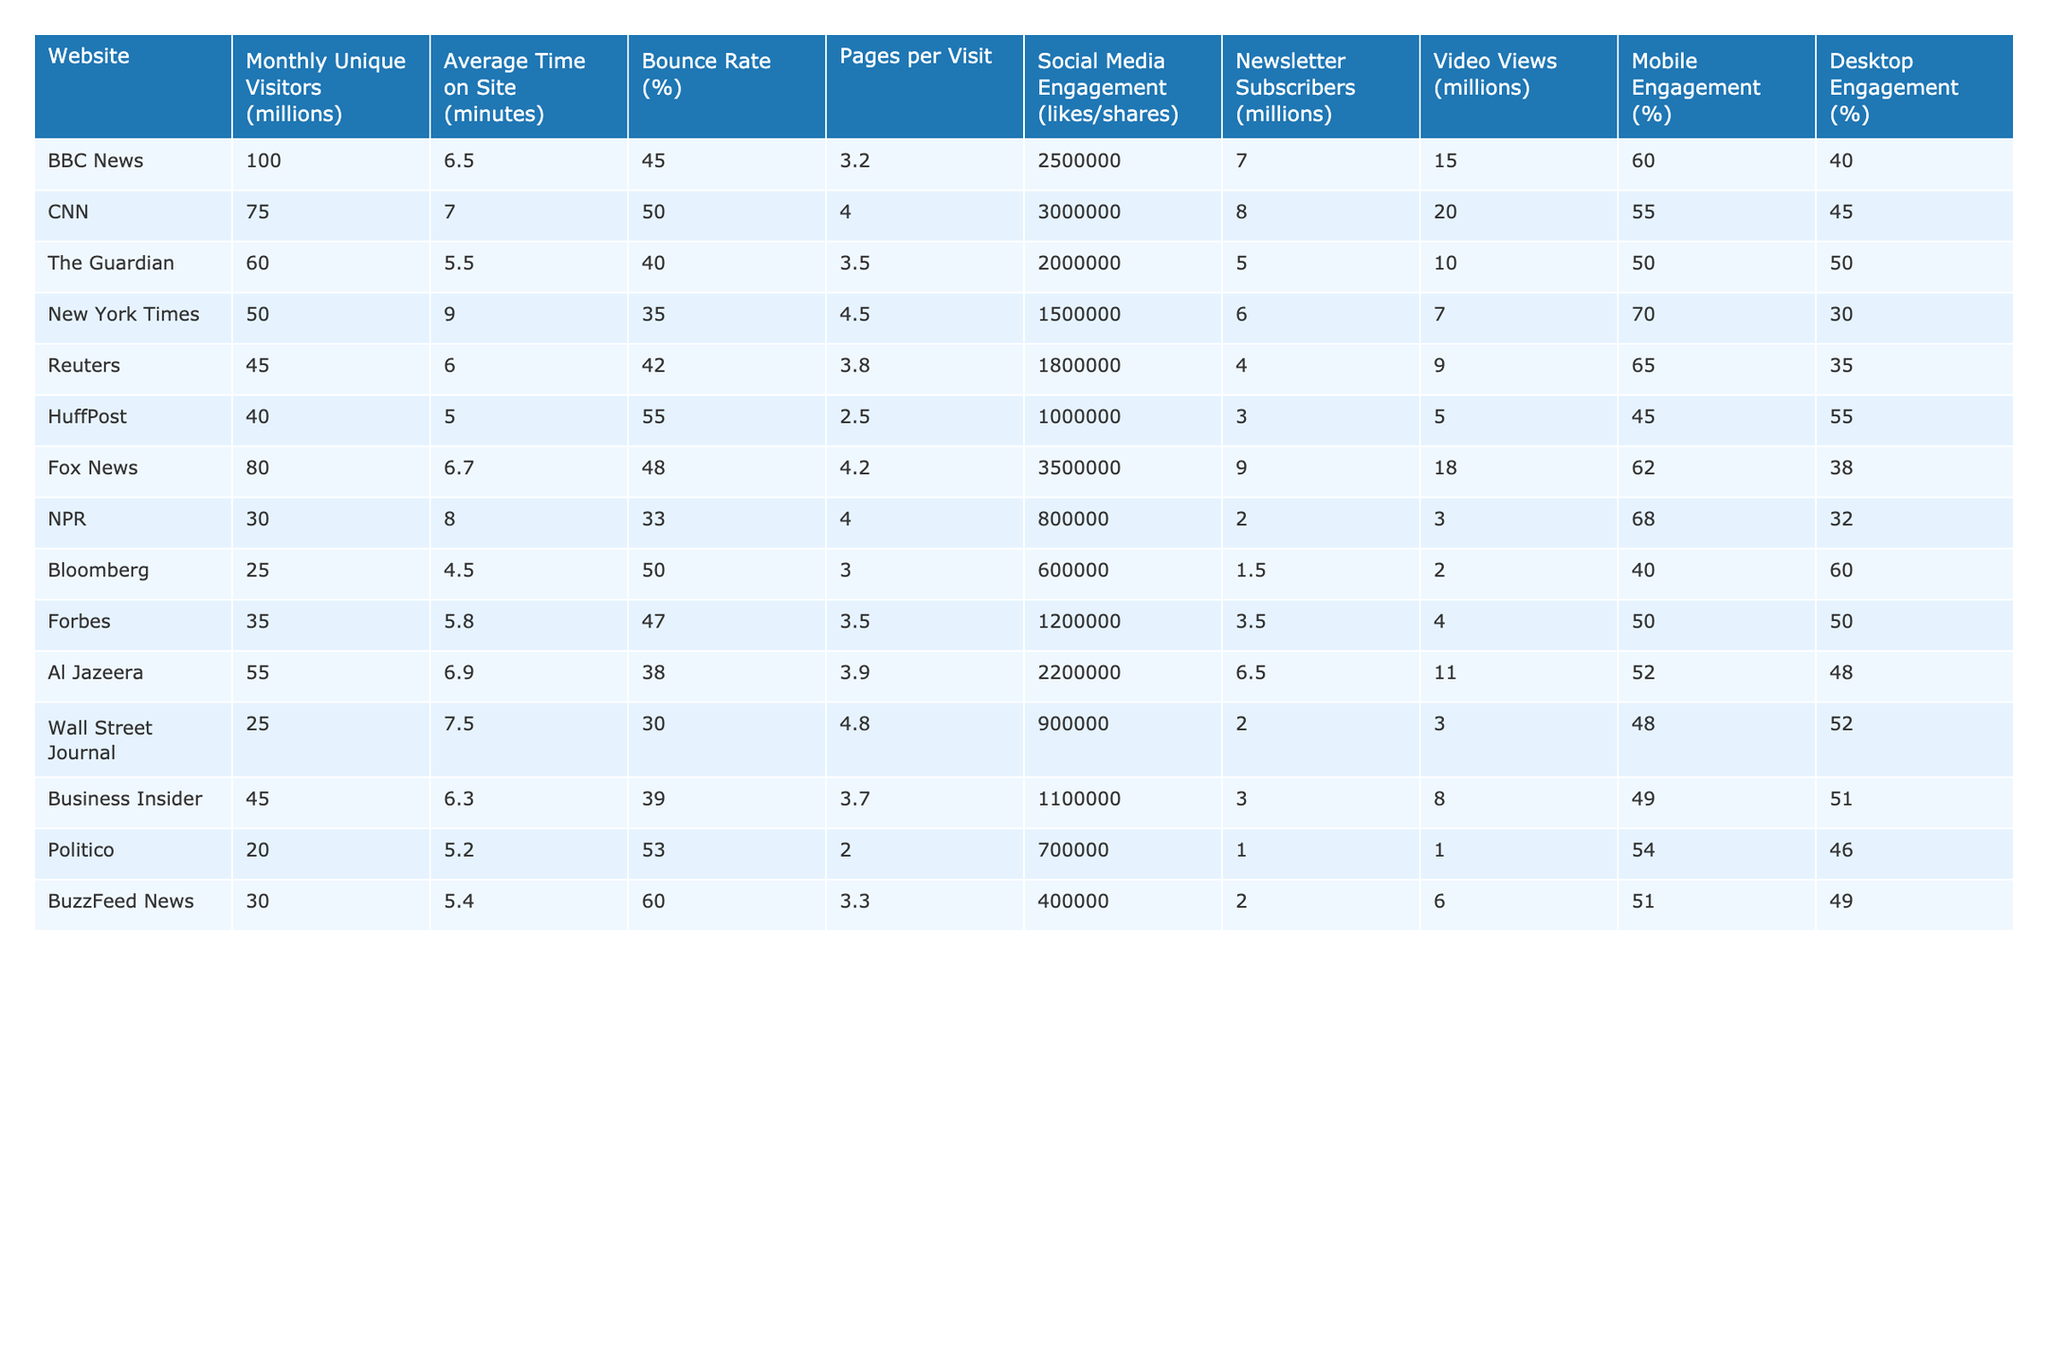What is the website with the highest monthly unique visitors? The table shows that BBC News has the highest monthly unique visitors at 100 million.
Answer: BBC News Which website has the lowest average time on site? Bloomberg has the lowest average time on site at 4.5 minutes.
Answer: Bloomberg What is the bounce rate for The Guardian? The bounce rate for The Guardian is 40%.
Answer: 40% Which two websites have a mobile engagement percentage greater than 60%? The websites NPR (68%) and BBC News (60%) have mobile engagement percentages greater than 60%.
Answer: NPR and BBC News What is the average number of social media engagements for the top five websites based on monthly unique visitors? Adding the social media engagements: 2,500,000 + 3,000,000 + 2,000,000 + 1,500,000 + 2,200,000 = 11,200,000; dividing by 5 gives an average of 2,240,000.
Answer: 2,240,000 Is the average number of pages per visit for CNN higher than that of Fox News? CNN has 4.0 pages per visit, while Fox News has 4.2, which is higher. Therefore, the statement is false.
Answer: No What is the difference in mobile engagement percentage between the highest and lowest? The highest mobile engagement is 70% (New York Times) and the lowest is 40% (Bloomberg), resulting in a difference of 30%.
Answer: 30% Which website has more newsletter subscribers, CNN or HuffPost? CNN has 8 million newsletter subscribers, while HuffPost has 3 million, which means CNN has more.
Answer: CNN What is the total number of video views for the websites that have a bounce rate below 40%? The websites with a bounce rate below 40% are The Guardian (10 million), NPR (3 million), and Wall Street Journal (3 million), summing to 16 million video views in total.
Answer: 16 million Which website has both the highest monthly unique visitors and average time on site? BBC News has the highest monthly unique visitors at 100 million and an average time on site of 6.5 minutes, making it the only website that meets both criteria.
Answer: BBC News 